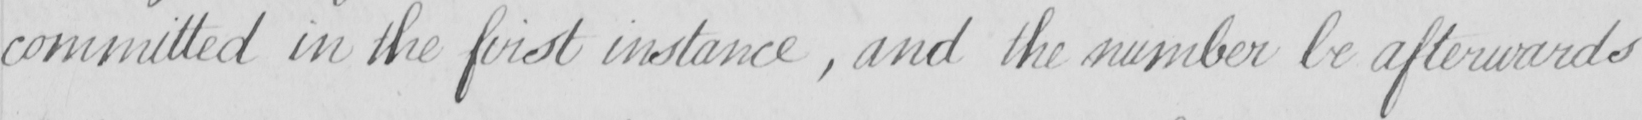Transcribe the text shown in this historical manuscript line. committed in the first instance , and the number be afterwards 